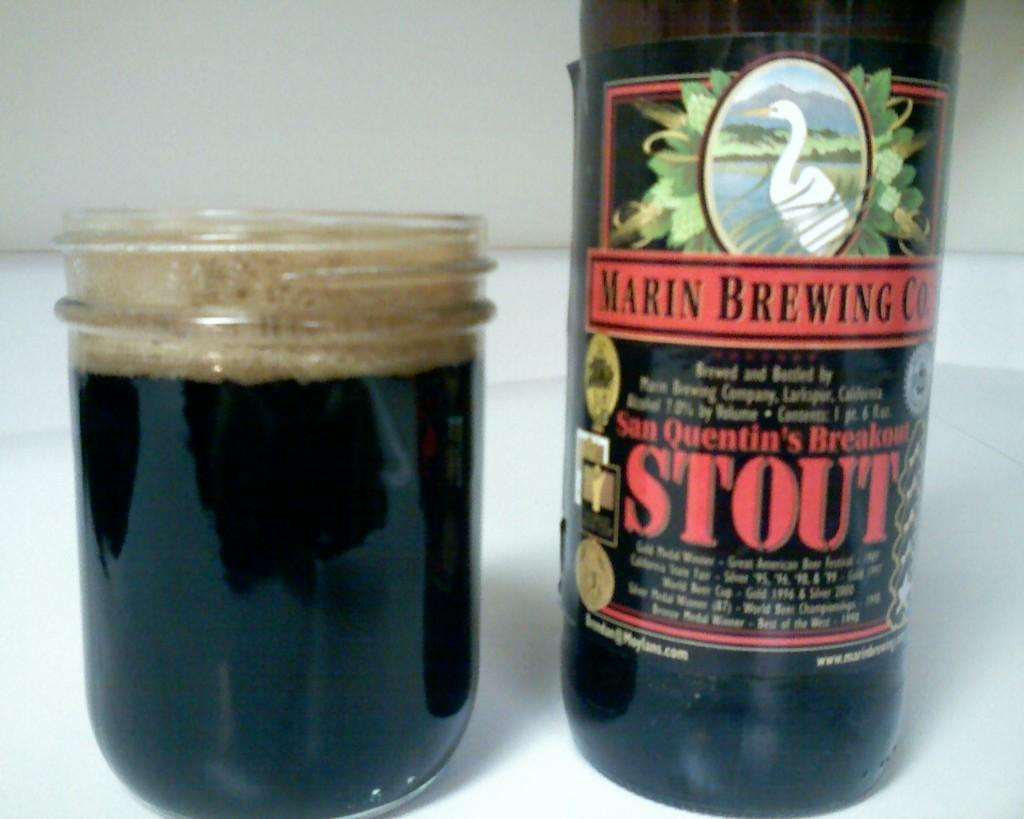What is one of the objects visible in the image? There is a bottle in the image. What is the other container visible in the image? There is a glass jar with liquid in the image. What is the color of the surface on which the bottle and glass jar are placed? The bottle and glass jar are on a white surface. What is the color of the background in the image? The background of the image is white. What type of song is being played in the background of the image? There is no music or sound present in the image, so it is not possible to determine what song might be playing. 